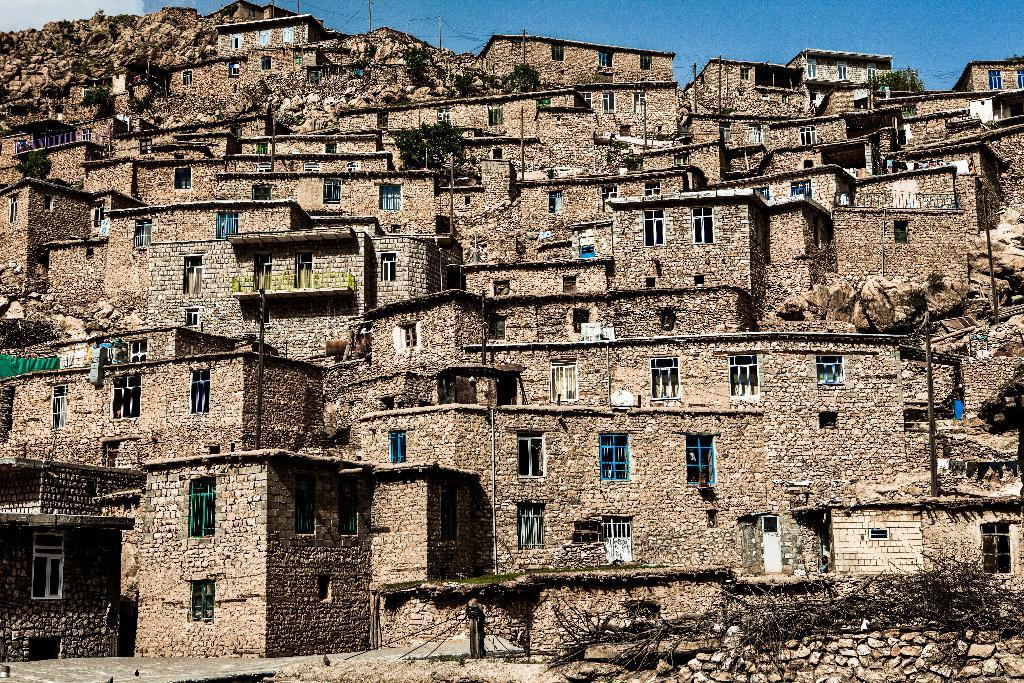What type of animals can be seen in the image? There are birds in the image. What natural elements are present in the image? There are dried sticks and trees in the image. What man-made structures can be seen in the image? There is a stone wall, buildings, poles, and windows in the image. What additional objects can be seen in the image? There are ropes in the image. What can be seen in the background of the image? In the background of the image, there are poles with wires and the sky is visible. How many bikes are parked near the stone wall in the image? There are no bikes present in the image. What type of adjustment can be made to the ropes in the image? There is no indication in the image that any adjustments need to be made to the ropes. 